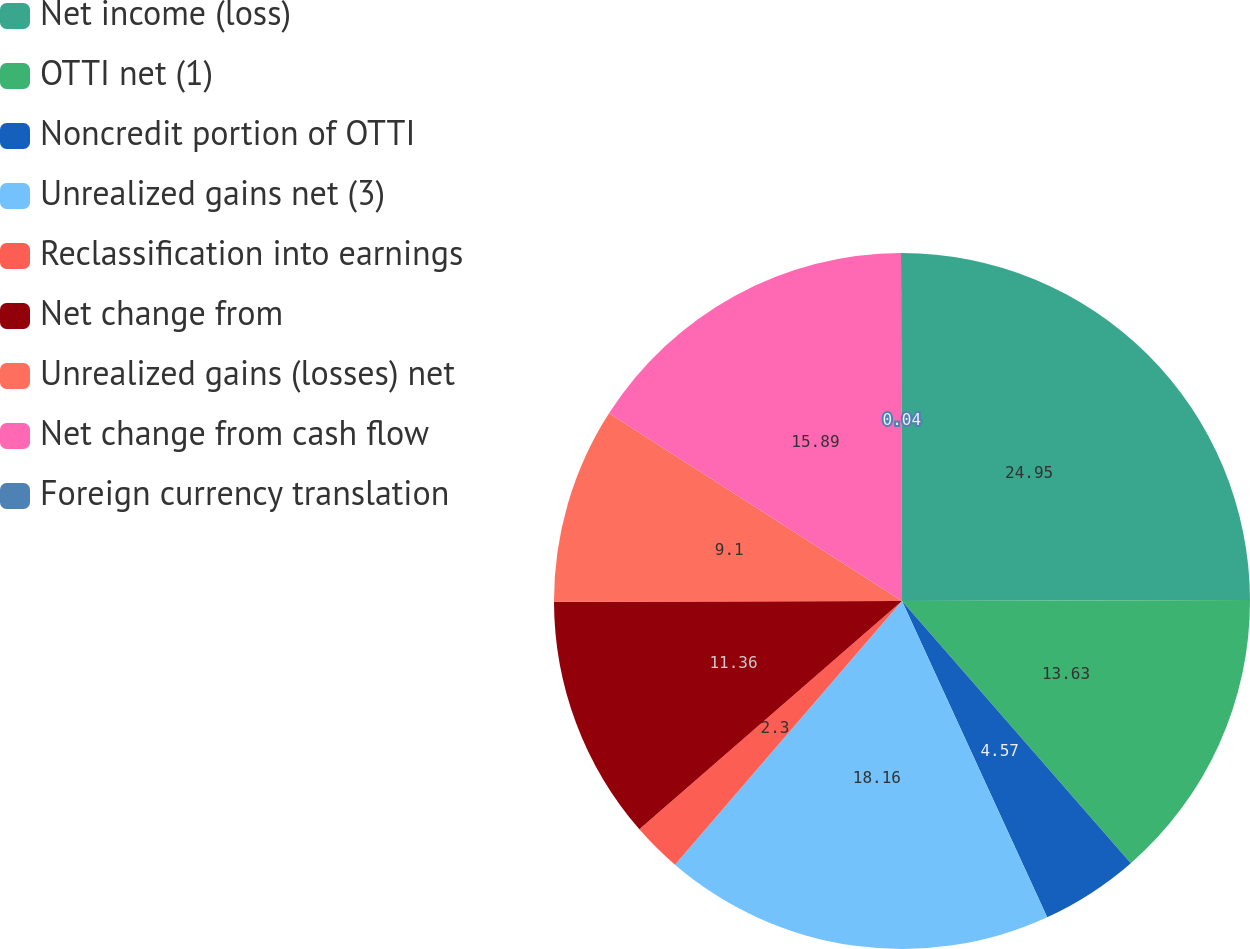<chart> <loc_0><loc_0><loc_500><loc_500><pie_chart><fcel>Net income (loss)<fcel>OTTI net (1)<fcel>Noncredit portion of OTTI<fcel>Unrealized gains net (3)<fcel>Reclassification into earnings<fcel>Net change from<fcel>Unrealized gains (losses) net<fcel>Net change from cash flow<fcel>Foreign currency translation<nl><fcel>24.95%<fcel>13.63%<fcel>4.57%<fcel>18.16%<fcel>2.3%<fcel>11.36%<fcel>9.1%<fcel>15.89%<fcel>0.04%<nl></chart> 